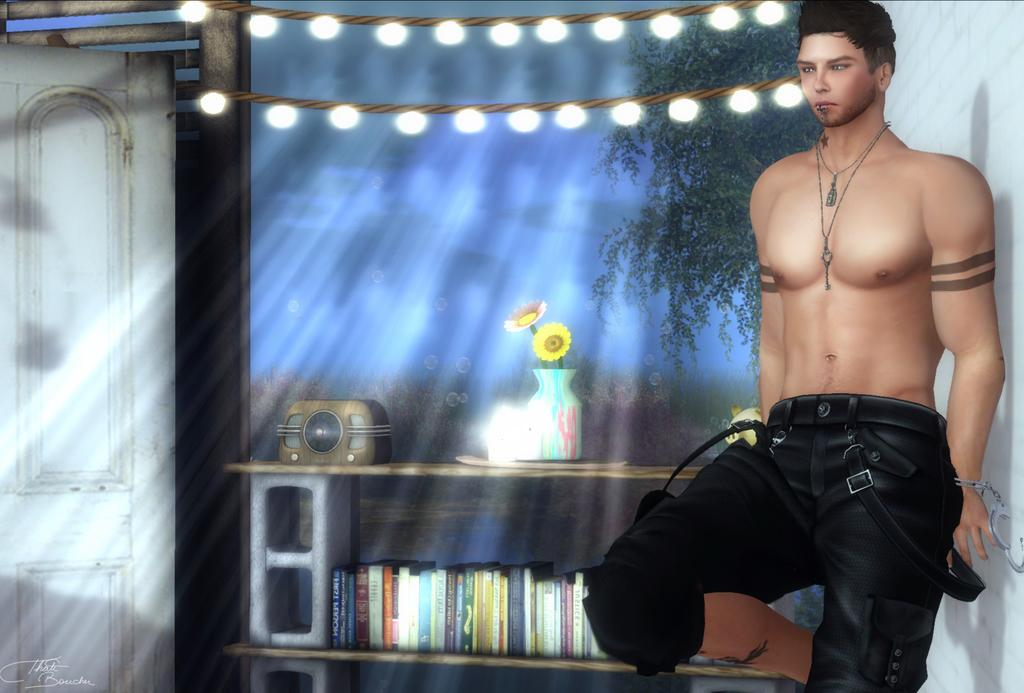What type of character is present in the image? There is an animated man in the image. What can be seen in the background of the image? There are lights, trees, a flower vase, a tape recorder, a door, and books in a shelf in the background of the image. Can you describe the setting of the image? The image appears to be set in a room with a background that includes various objects and features. What type of group activity is the bear participating in with the animated man in the image? There is no bear present in the image, so it is not possible to answer that question. 